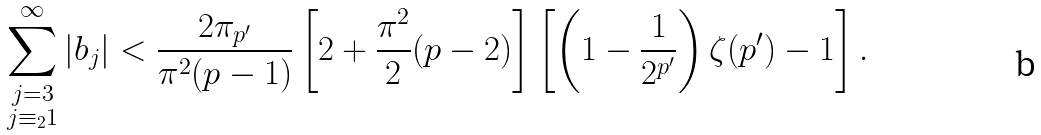Convert formula to latex. <formula><loc_0><loc_0><loc_500><loc_500>\sum _ { \substack { j = 3 \\ j \equiv _ { 2 } 1 } } ^ { \infty } | b _ { j } | < \frac { 2 \pi _ { p ^ { \prime } } } { \pi ^ { 2 } ( p - 1 ) } \left [ 2 + \frac { \pi ^ { 2 } } { 2 } ( p - 2 ) \right ] \left [ \left ( 1 - \frac { 1 } { 2 ^ { p ^ { \prime } } } \right ) \zeta ( p ^ { \prime } ) - 1 \right ] .</formula> 